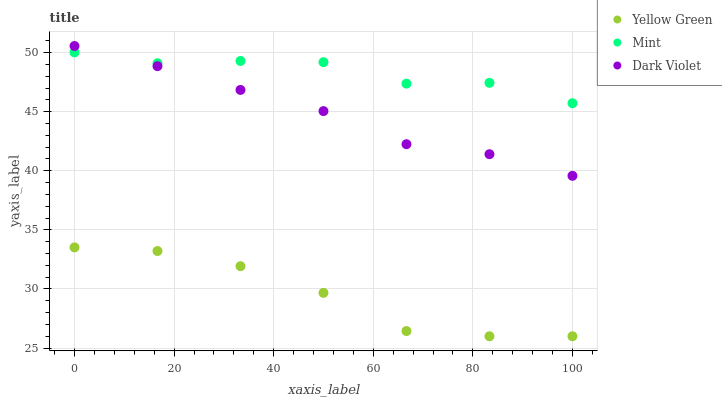Does Yellow Green have the minimum area under the curve?
Answer yes or no. Yes. Does Mint have the maximum area under the curve?
Answer yes or no. Yes. Does Dark Violet have the minimum area under the curve?
Answer yes or no. No. Does Dark Violet have the maximum area under the curve?
Answer yes or no. No. Is Dark Violet the smoothest?
Answer yes or no. Yes. Is Mint the roughest?
Answer yes or no. Yes. Is Yellow Green the smoothest?
Answer yes or no. No. Is Yellow Green the roughest?
Answer yes or no. No. Does Yellow Green have the lowest value?
Answer yes or no. Yes. Does Dark Violet have the lowest value?
Answer yes or no. No. Does Dark Violet have the highest value?
Answer yes or no. Yes. Does Yellow Green have the highest value?
Answer yes or no. No. Is Yellow Green less than Dark Violet?
Answer yes or no. Yes. Is Dark Violet greater than Yellow Green?
Answer yes or no. Yes. Does Dark Violet intersect Mint?
Answer yes or no. Yes. Is Dark Violet less than Mint?
Answer yes or no. No. Is Dark Violet greater than Mint?
Answer yes or no. No. Does Yellow Green intersect Dark Violet?
Answer yes or no. No. 